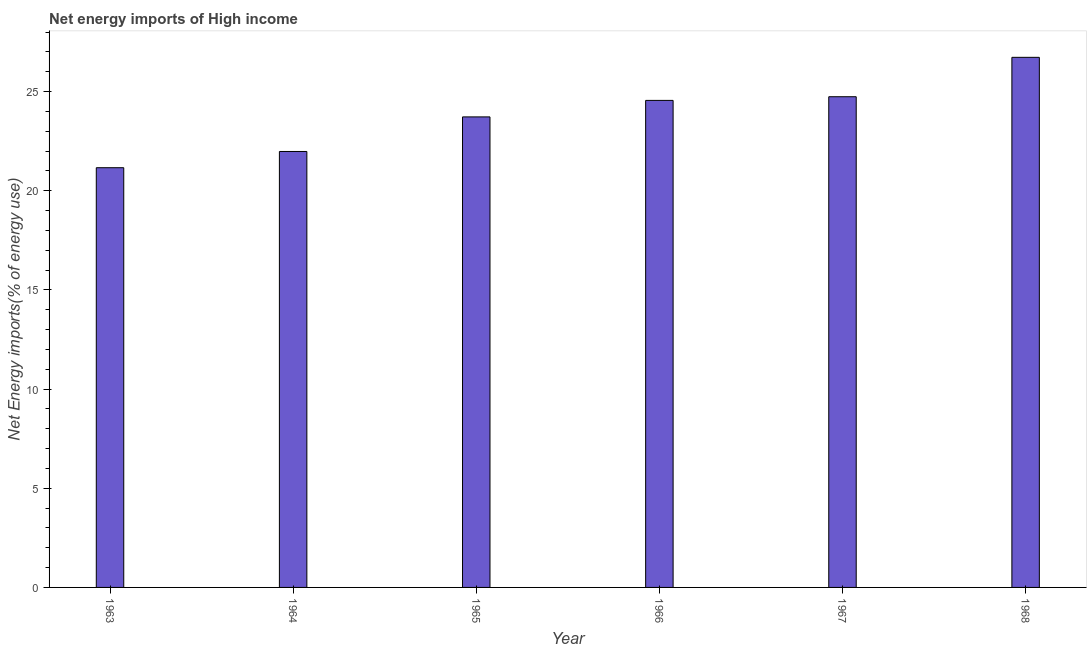Does the graph contain grids?
Your answer should be very brief. No. What is the title of the graph?
Your answer should be compact. Net energy imports of High income. What is the label or title of the Y-axis?
Your answer should be very brief. Net Energy imports(% of energy use). What is the energy imports in 1967?
Your answer should be very brief. 24.74. Across all years, what is the maximum energy imports?
Make the answer very short. 26.72. Across all years, what is the minimum energy imports?
Keep it short and to the point. 21.16. In which year was the energy imports maximum?
Ensure brevity in your answer.  1968. In which year was the energy imports minimum?
Provide a succinct answer. 1963. What is the sum of the energy imports?
Give a very brief answer. 142.87. What is the difference between the energy imports in 1963 and 1968?
Your answer should be compact. -5.57. What is the average energy imports per year?
Your answer should be very brief. 23.81. What is the median energy imports?
Offer a very short reply. 24.14. In how many years, is the energy imports greater than 4 %?
Your answer should be compact. 6. Do a majority of the years between 1964 and 1965 (inclusive) have energy imports greater than 11 %?
Keep it short and to the point. Yes. What is the ratio of the energy imports in 1966 to that in 1968?
Make the answer very short. 0.92. What is the difference between the highest and the second highest energy imports?
Provide a succinct answer. 1.99. Is the sum of the energy imports in 1967 and 1968 greater than the maximum energy imports across all years?
Make the answer very short. Yes. What is the difference between the highest and the lowest energy imports?
Provide a short and direct response. 5.56. In how many years, is the energy imports greater than the average energy imports taken over all years?
Ensure brevity in your answer.  3. What is the difference between two consecutive major ticks on the Y-axis?
Your response must be concise. 5. Are the values on the major ticks of Y-axis written in scientific E-notation?
Make the answer very short. No. What is the Net Energy imports(% of energy use) in 1963?
Provide a short and direct response. 21.16. What is the Net Energy imports(% of energy use) of 1964?
Your response must be concise. 21.98. What is the Net Energy imports(% of energy use) in 1965?
Give a very brief answer. 23.72. What is the Net Energy imports(% of energy use) of 1966?
Provide a short and direct response. 24.55. What is the Net Energy imports(% of energy use) in 1967?
Make the answer very short. 24.74. What is the Net Energy imports(% of energy use) of 1968?
Provide a succinct answer. 26.72. What is the difference between the Net Energy imports(% of energy use) in 1963 and 1964?
Give a very brief answer. -0.82. What is the difference between the Net Energy imports(% of energy use) in 1963 and 1965?
Make the answer very short. -2.56. What is the difference between the Net Energy imports(% of energy use) in 1963 and 1966?
Your answer should be very brief. -3.39. What is the difference between the Net Energy imports(% of energy use) in 1963 and 1967?
Ensure brevity in your answer.  -3.58. What is the difference between the Net Energy imports(% of energy use) in 1963 and 1968?
Offer a very short reply. -5.56. What is the difference between the Net Energy imports(% of energy use) in 1964 and 1965?
Make the answer very short. -1.74. What is the difference between the Net Energy imports(% of energy use) in 1964 and 1966?
Your response must be concise. -2.57. What is the difference between the Net Energy imports(% of energy use) in 1964 and 1967?
Give a very brief answer. -2.76. What is the difference between the Net Energy imports(% of energy use) in 1964 and 1968?
Your response must be concise. -4.75. What is the difference between the Net Energy imports(% of energy use) in 1965 and 1966?
Provide a short and direct response. -0.83. What is the difference between the Net Energy imports(% of energy use) in 1965 and 1967?
Ensure brevity in your answer.  -1.02. What is the difference between the Net Energy imports(% of energy use) in 1965 and 1968?
Your answer should be very brief. -3. What is the difference between the Net Energy imports(% of energy use) in 1966 and 1967?
Offer a terse response. -0.19. What is the difference between the Net Energy imports(% of energy use) in 1966 and 1968?
Your response must be concise. -2.17. What is the difference between the Net Energy imports(% of energy use) in 1967 and 1968?
Offer a very short reply. -1.99. What is the ratio of the Net Energy imports(% of energy use) in 1963 to that in 1965?
Offer a very short reply. 0.89. What is the ratio of the Net Energy imports(% of energy use) in 1963 to that in 1966?
Keep it short and to the point. 0.86. What is the ratio of the Net Energy imports(% of energy use) in 1963 to that in 1967?
Provide a succinct answer. 0.85. What is the ratio of the Net Energy imports(% of energy use) in 1963 to that in 1968?
Your answer should be compact. 0.79. What is the ratio of the Net Energy imports(% of energy use) in 1964 to that in 1965?
Offer a very short reply. 0.93. What is the ratio of the Net Energy imports(% of energy use) in 1964 to that in 1966?
Offer a very short reply. 0.9. What is the ratio of the Net Energy imports(% of energy use) in 1964 to that in 1967?
Your answer should be compact. 0.89. What is the ratio of the Net Energy imports(% of energy use) in 1964 to that in 1968?
Offer a very short reply. 0.82. What is the ratio of the Net Energy imports(% of energy use) in 1965 to that in 1967?
Make the answer very short. 0.96. What is the ratio of the Net Energy imports(% of energy use) in 1965 to that in 1968?
Make the answer very short. 0.89. What is the ratio of the Net Energy imports(% of energy use) in 1966 to that in 1967?
Make the answer very short. 0.99. What is the ratio of the Net Energy imports(% of energy use) in 1966 to that in 1968?
Make the answer very short. 0.92. What is the ratio of the Net Energy imports(% of energy use) in 1967 to that in 1968?
Provide a succinct answer. 0.93. 